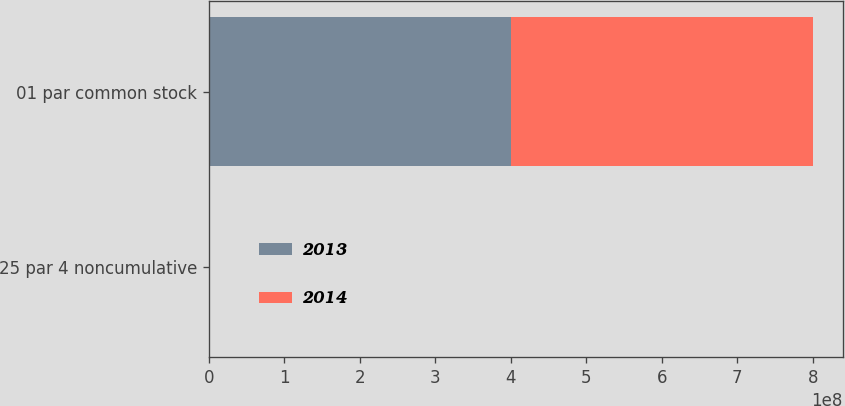Convert chart. <chart><loc_0><loc_0><loc_500><loc_500><stacked_bar_chart><ecel><fcel>25 par 4 noncumulative<fcel>01 par common stock<nl><fcel>2013<fcel>840000<fcel>4e+08<nl><fcel>2014<fcel>840000<fcel>4e+08<nl></chart> 